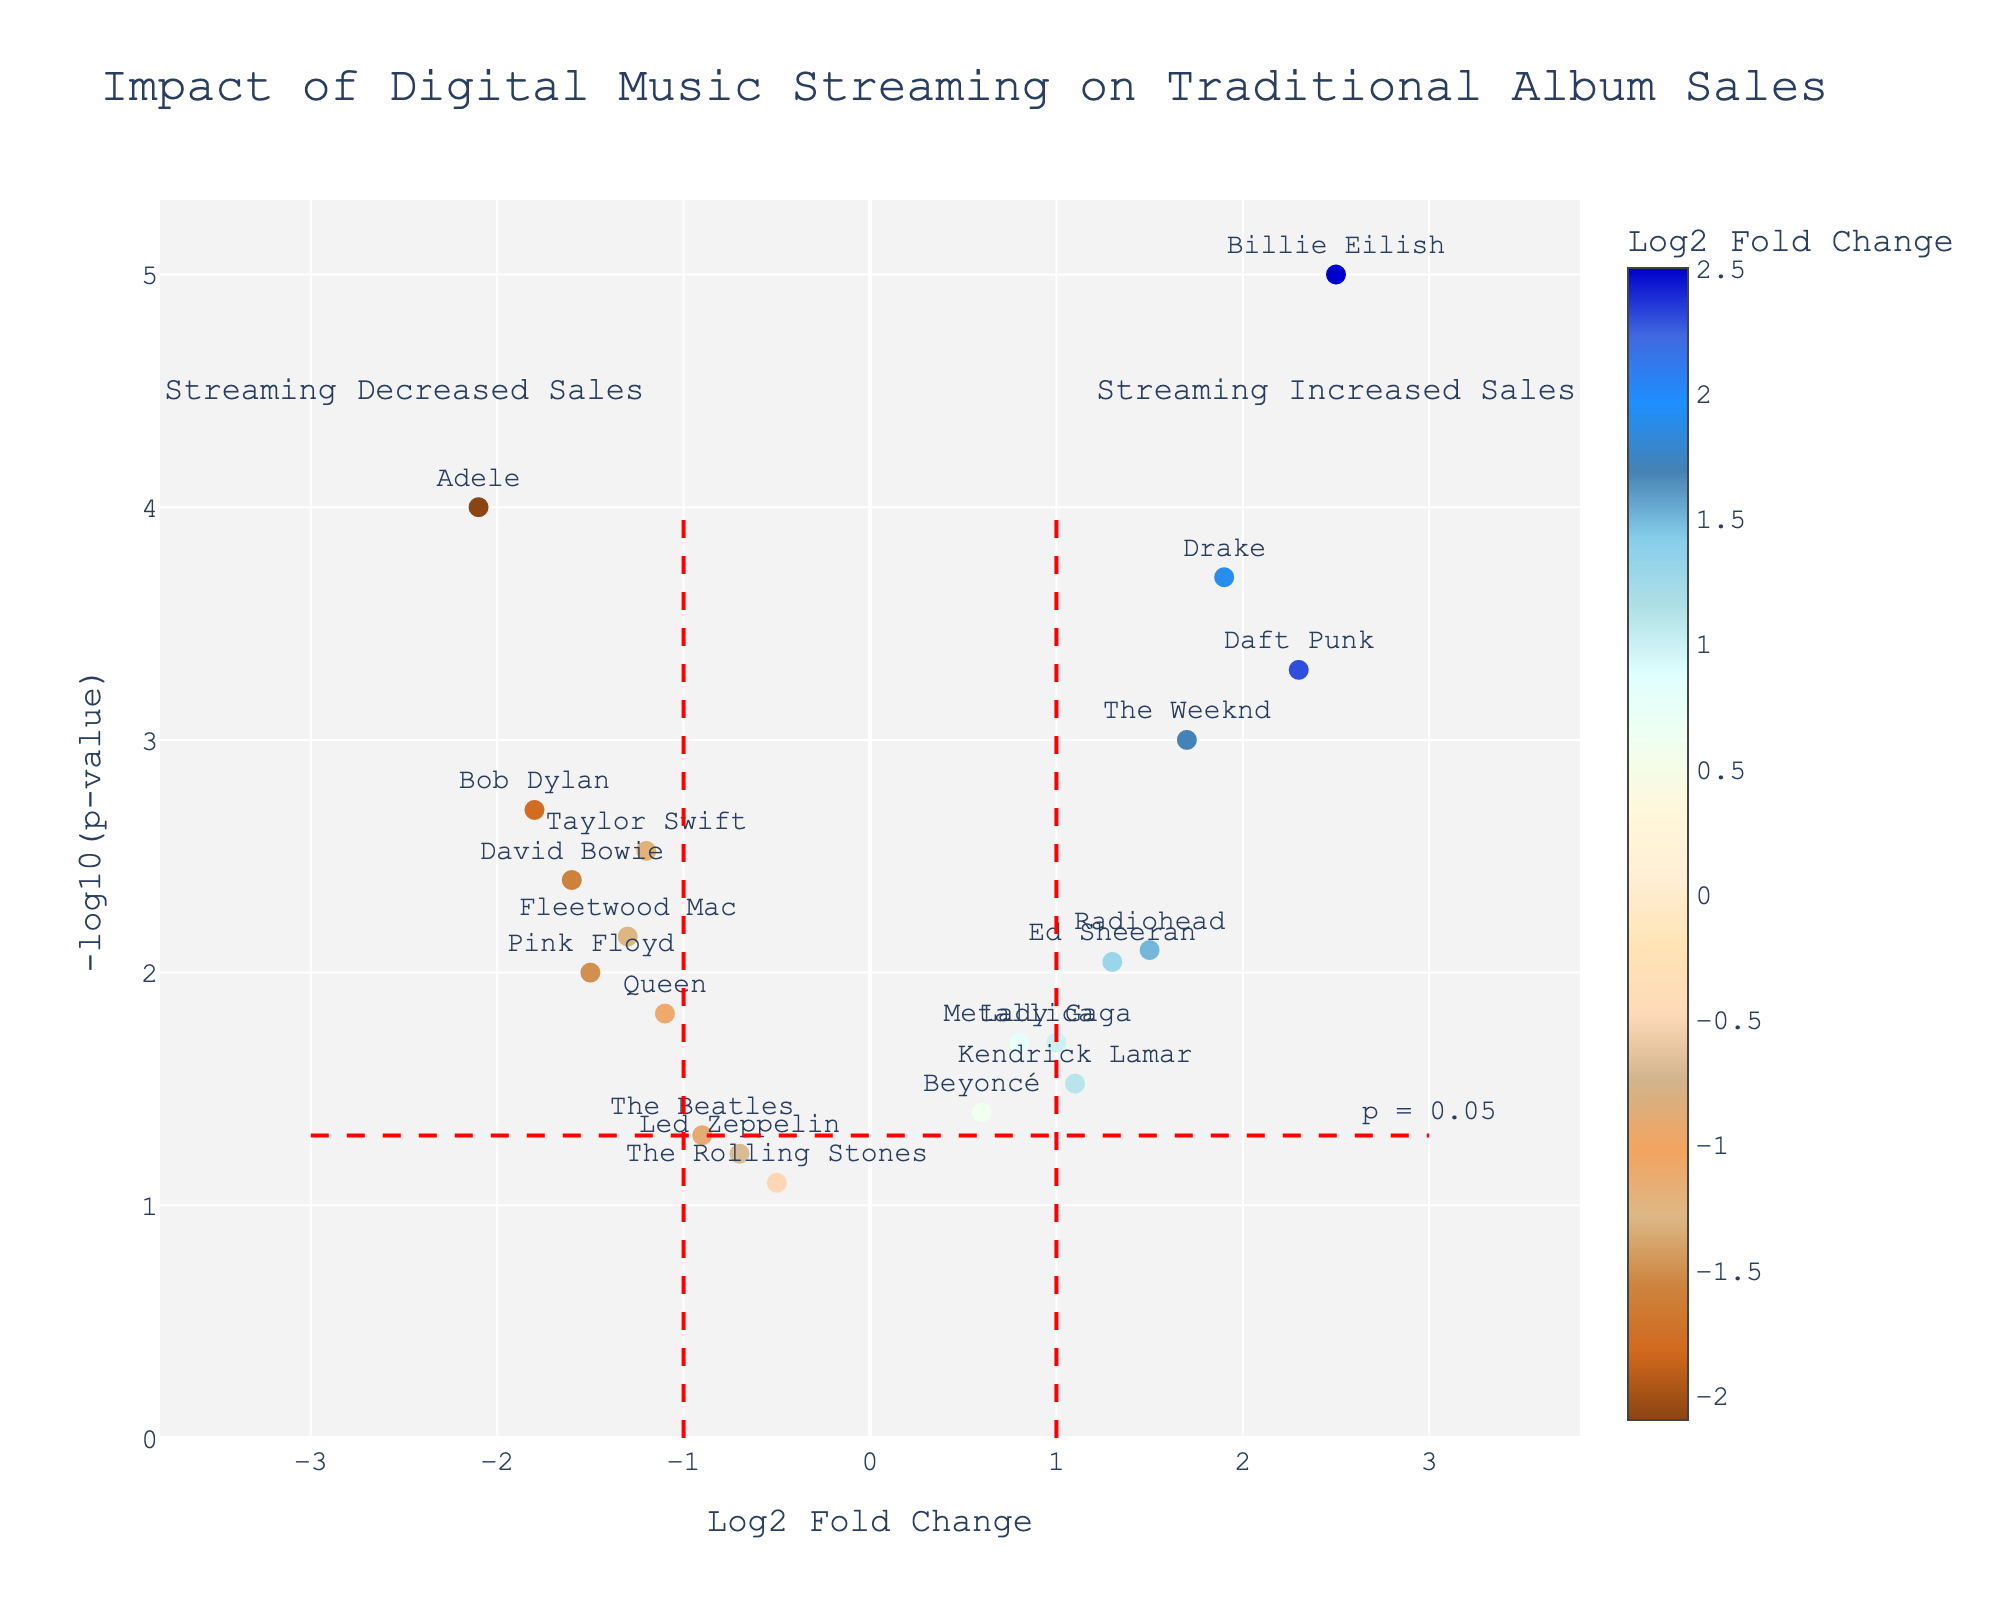What is the title of the figure? The title is typically located at the top center of the plot. Here, it reads "Impact of Digital Music Streaming on Traditional Album Sales."
Answer: Impact of Digital Music Streaming on Traditional Album Sales Which artist has the highest positive log2 fold change in the plot? By looking at the x-axis values (log2 fold change), the highest positive value is 2.5, and it corresponds to Billie Eilish.
Answer: Billie Eilish How many artists have a p-value less than 0.01? To find this, count the number of points above the horizontal line at -log10(p-value) = 2 (since -log10(0.01)=2). This includes Adele, Daft Punk, The Weeknd, Billie Eilish, Drake, Bob Dylan, Taylor Swift, and David Bowie. There are 8 artists.
Answer: 8 What do the vertical red dashed lines represent? The vertical red dashed lines are boundaries for 'log2 fold change' at -1 and 1. Artists outside these lines show significant changes in album sales, either increase (right) or decrease (left).
Answer: Boundaries for significant changes Which two artists show a significant decrease in album sales due to streaming with a p-value less than 0.005? First, identify artists to the left of the vertical red line at -1 with a high -log10(p-value). These are Adele and Bob Dylan, both above the horizontal red line.
Answer: Adele and Bob Dylan Which artist has a log2 fold change close to 0 but a significant p-value? Focus on the region around log2 fold change of 0 on the x-axis and look for artists with high -log10(p-value). The Beatles, with a p-value of 0.05 (close to horizontal red line at 1.3), fits this.
Answer: The Beatles What does the region labeled "Streaming Decreased Sales" refer to? This text is near the top left side of the plot. It refers to artists with a log2 fold change less than -1, indicating significant decreases in album sales from streaming.
Answer: Artists with a log2 fold change less than -1 Compare the impact of streaming on sales for Radiohead and Beyoncé. Look at their log2 fold changes and p-values. Radiohead has a log2 fold change of 1.5 and Beyoncé has 0.6. Both are positive, but Radiohead's impact is higher.
Answer: Radiohead has a higher impact Which two artists have notable increases in sales with very small p-values? Look to the right of the vertical red line at 1 with high -log10(p-value) values. These are Billie Eilish (2.5, p-value of 0.00001) and Drake (1.9, p-value of 0.0002).
Answer: Billie Eilish and Drake 